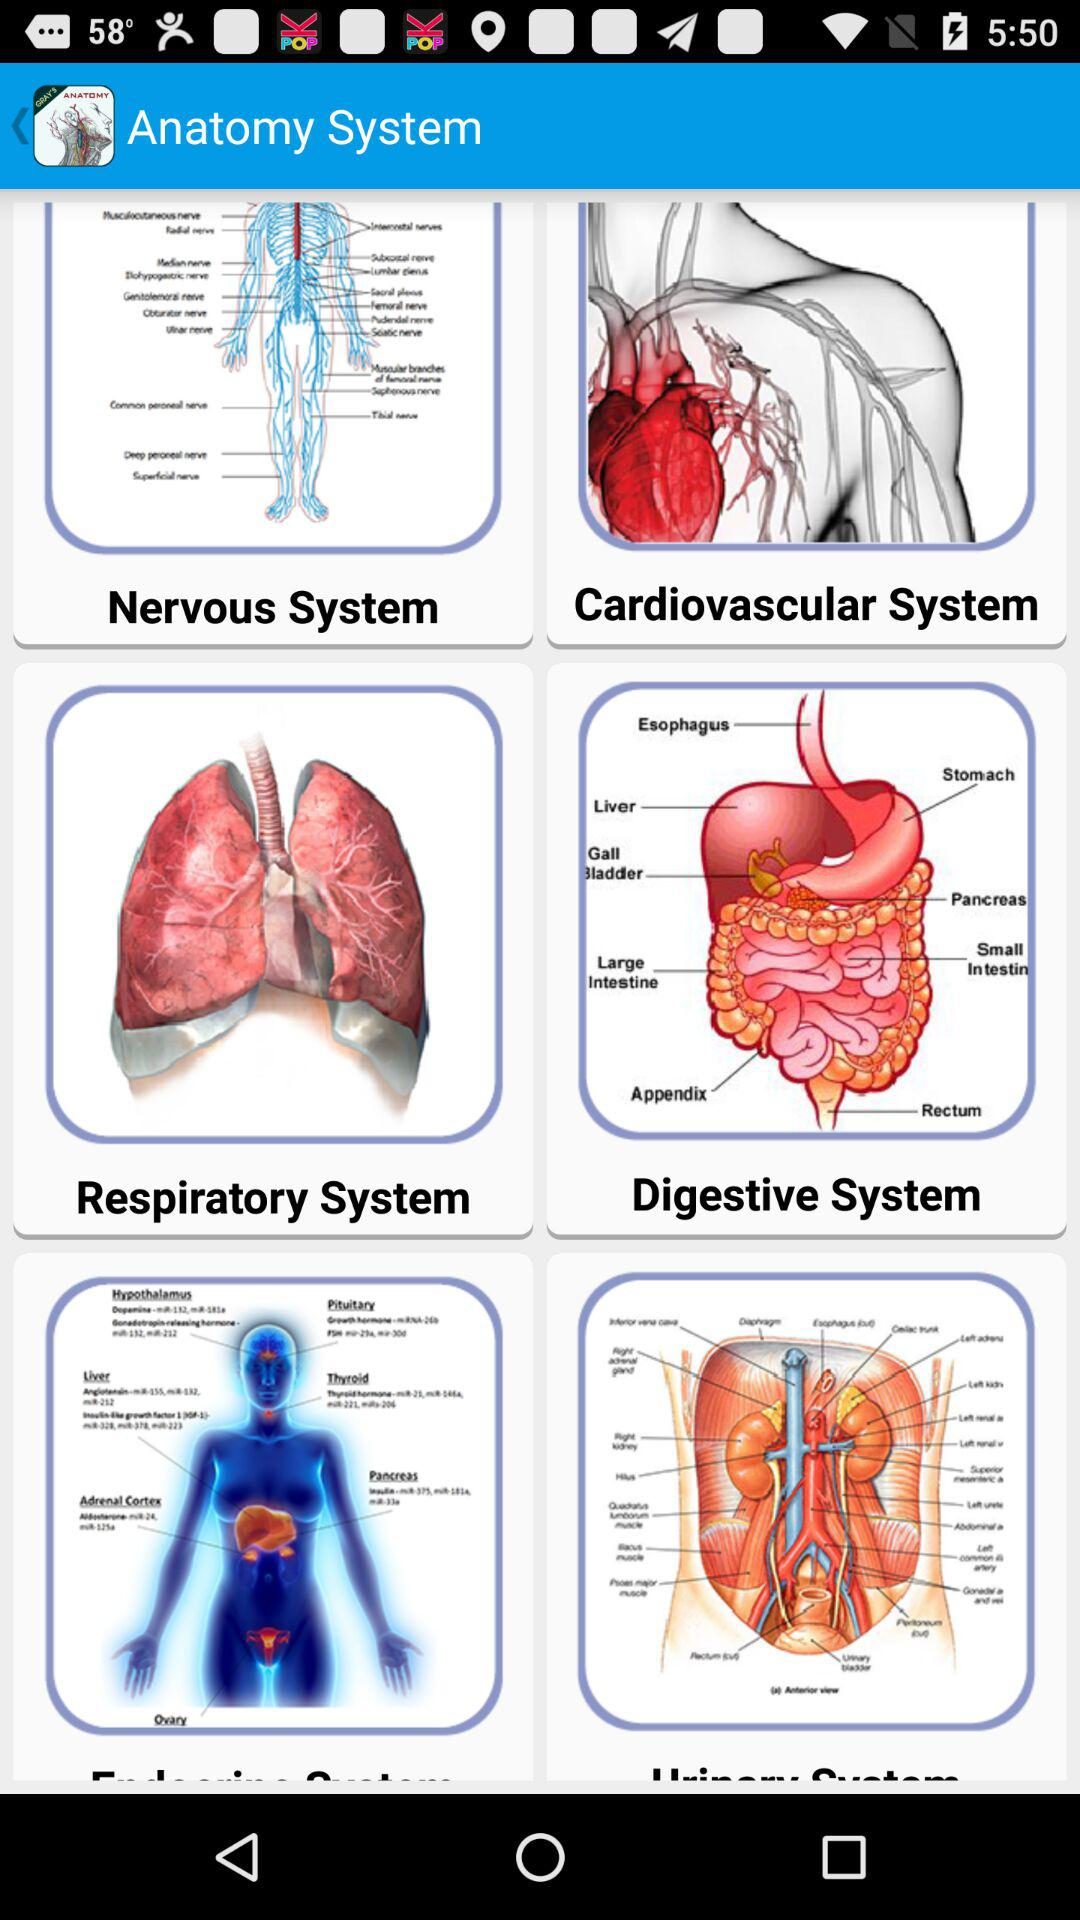What is the name of the application? The name of the application is "Gray's Anatomy - Anatomy Atlas". 